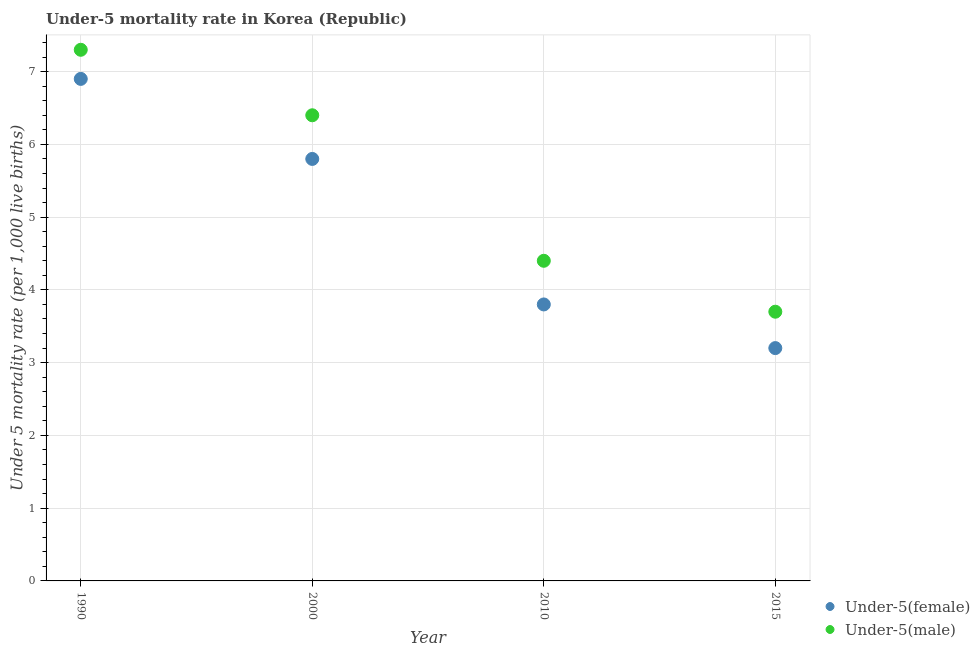What is the under-5 female mortality rate in 2015?
Offer a terse response. 3.2. Across all years, what is the minimum under-5 female mortality rate?
Provide a succinct answer. 3.2. In which year was the under-5 male mortality rate minimum?
Provide a short and direct response. 2015. What is the total under-5 male mortality rate in the graph?
Your response must be concise. 21.8. What is the difference between the under-5 male mortality rate in 1990 and that in 2010?
Offer a terse response. 2.9. What is the average under-5 male mortality rate per year?
Offer a very short reply. 5.45. In the year 2000, what is the difference between the under-5 female mortality rate and under-5 male mortality rate?
Provide a succinct answer. -0.6. What is the ratio of the under-5 male mortality rate in 2000 to that in 2015?
Offer a terse response. 1.73. Is the under-5 female mortality rate in 2000 less than that in 2015?
Offer a very short reply. No. Is the difference between the under-5 female mortality rate in 1990 and 2010 greater than the difference between the under-5 male mortality rate in 1990 and 2010?
Your answer should be compact. Yes. What is the difference between the highest and the second highest under-5 female mortality rate?
Provide a short and direct response. 1.1. What is the difference between the highest and the lowest under-5 male mortality rate?
Your answer should be very brief. 3.6. In how many years, is the under-5 male mortality rate greater than the average under-5 male mortality rate taken over all years?
Offer a very short reply. 2. Is the under-5 female mortality rate strictly greater than the under-5 male mortality rate over the years?
Your answer should be very brief. No. Is the under-5 female mortality rate strictly less than the under-5 male mortality rate over the years?
Provide a short and direct response. Yes. How many dotlines are there?
Offer a very short reply. 2. How many years are there in the graph?
Give a very brief answer. 4. Are the values on the major ticks of Y-axis written in scientific E-notation?
Ensure brevity in your answer.  No. Does the graph contain any zero values?
Your response must be concise. No. How are the legend labels stacked?
Provide a succinct answer. Vertical. What is the title of the graph?
Make the answer very short. Under-5 mortality rate in Korea (Republic). Does "Diesel" appear as one of the legend labels in the graph?
Ensure brevity in your answer.  No. What is the label or title of the X-axis?
Make the answer very short. Year. What is the label or title of the Y-axis?
Offer a very short reply. Under 5 mortality rate (per 1,0 live births). What is the Under 5 mortality rate (per 1,000 live births) of Under-5(female) in 2000?
Provide a short and direct response. 5.8. What is the Under 5 mortality rate (per 1,000 live births) in Under-5(male) in 2000?
Keep it short and to the point. 6.4. What is the Under 5 mortality rate (per 1,000 live births) of Under-5(female) in 2010?
Your answer should be very brief. 3.8. What is the Under 5 mortality rate (per 1,000 live births) of Under-5(male) in 2010?
Keep it short and to the point. 4.4. What is the Under 5 mortality rate (per 1,000 live births) of Under-5(male) in 2015?
Provide a short and direct response. 3.7. Across all years, what is the maximum Under 5 mortality rate (per 1,000 live births) in Under-5(female)?
Make the answer very short. 6.9. Across all years, what is the minimum Under 5 mortality rate (per 1,000 live births) of Under-5(female)?
Your response must be concise. 3.2. What is the total Under 5 mortality rate (per 1,000 live births) of Under-5(male) in the graph?
Provide a short and direct response. 21.8. What is the difference between the Under 5 mortality rate (per 1,000 live births) of Under-5(female) in 1990 and that in 2000?
Your answer should be compact. 1.1. What is the difference between the Under 5 mortality rate (per 1,000 live births) in Under-5(male) in 1990 and that in 2000?
Keep it short and to the point. 0.9. What is the difference between the Under 5 mortality rate (per 1,000 live births) in Under-5(male) in 1990 and that in 2015?
Your answer should be compact. 3.6. What is the difference between the Under 5 mortality rate (per 1,000 live births) of Under-5(female) in 2000 and that in 2010?
Provide a short and direct response. 2. What is the difference between the Under 5 mortality rate (per 1,000 live births) in Under-5(male) in 2000 and that in 2015?
Give a very brief answer. 2.7. What is the difference between the Under 5 mortality rate (per 1,000 live births) in Under-5(female) in 2010 and that in 2015?
Keep it short and to the point. 0.6. What is the difference between the Under 5 mortality rate (per 1,000 live births) of Under-5(male) in 2010 and that in 2015?
Your answer should be compact. 0.7. What is the difference between the Under 5 mortality rate (per 1,000 live births) in Under-5(female) in 2010 and the Under 5 mortality rate (per 1,000 live births) in Under-5(male) in 2015?
Your response must be concise. 0.1. What is the average Under 5 mortality rate (per 1,000 live births) in Under-5(female) per year?
Offer a very short reply. 4.92. What is the average Under 5 mortality rate (per 1,000 live births) of Under-5(male) per year?
Your response must be concise. 5.45. In the year 2000, what is the difference between the Under 5 mortality rate (per 1,000 live births) in Under-5(female) and Under 5 mortality rate (per 1,000 live births) in Under-5(male)?
Ensure brevity in your answer.  -0.6. In the year 2015, what is the difference between the Under 5 mortality rate (per 1,000 live births) of Under-5(female) and Under 5 mortality rate (per 1,000 live births) of Under-5(male)?
Give a very brief answer. -0.5. What is the ratio of the Under 5 mortality rate (per 1,000 live births) in Under-5(female) in 1990 to that in 2000?
Ensure brevity in your answer.  1.19. What is the ratio of the Under 5 mortality rate (per 1,000 live births) in Under-5(male) in 1990 to that in 2000?
Provide a short and direct response. 1.14. What is the ratio of the Under 5 mortality rate (per 1,000 live births) in Under-5(female) in 1990 to that in 2010?
Keep it short and to the point. 1.82. What is the ratio of the Under 5 mortality rate (per 1,000 live births) of Under-5(male) in 1990 to that in 2010?
Provide a short and direct response. 1.66. What is the ratio of the Under 5 mortality rate (per 1,000 live births) in Under-5(female) in 1990 to that in 2015?
Keep it short and to the point. 2.16. What is the ratio of the Under 5 mortality rate (per 1,000 live births) in Under-5(male) in 1990 to that in 2015?
Provide a short and direct response. 1.97. What is the ratio of the Under 5 mortality rate (per 1,000 live births) of Under-5(female) in 2000 to that in 2010?
Offer a very short reply. 1.53. What is the ratio of the Under 5 mortality rate (per 1,000 live births) in Under-5(male) in 2000 to that in 2010?
Offer a very short reply. 1.45. What is the ratio of the Under 5 mortality rate (per 1,000 live births) in Under-5(female) in 2000 to that in 2015?
Provide a short and direct response. 1.81. What is the ratio of the Under 5 mortality rate (per 1,000 live births) in Under-5(male) in 2000 to that in 2015?
Provide a succinct answer. 1.73. What is the ratio of the Under 5 mortality rate (per 1,000 live births) in Under-5(female) in 2010 to that in 2015?
Ensure brevity in your answer.  1.19. What is the ratio of the Under 5 mortality rate (per 1,000 live births) of Under-5(male) in 2010 to that in 2015?
Your answer should be very brief. 1.19. 